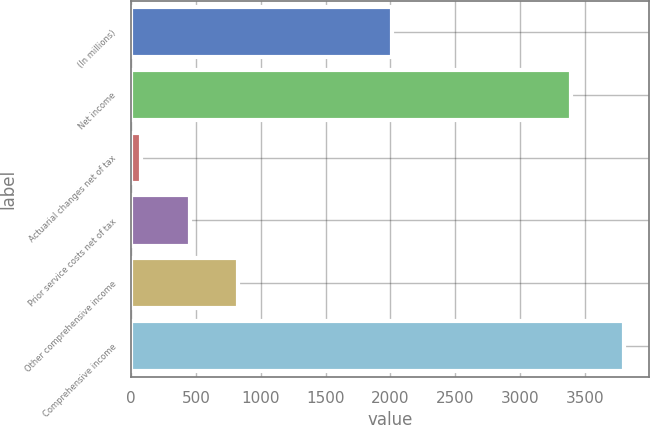Convert chart. <chart><loc_0><loc_0><loc_500><loc_500><bar_chart><fcel>(In millions)<fcel>Net income<fcel>Actuarial changes net of tax<fcel>Prior service costs net of tax<fcel>Other comprehensive income<fcel>Comprehensive income<nl><fcel>2012<fcel>3393<fcel>78<fcel>451<fcel>824<fcel>3804<nl></chart> 